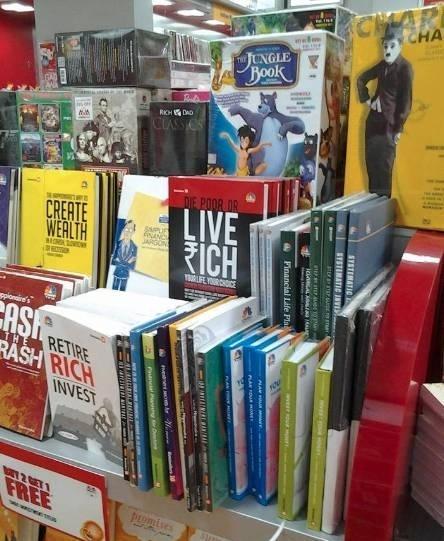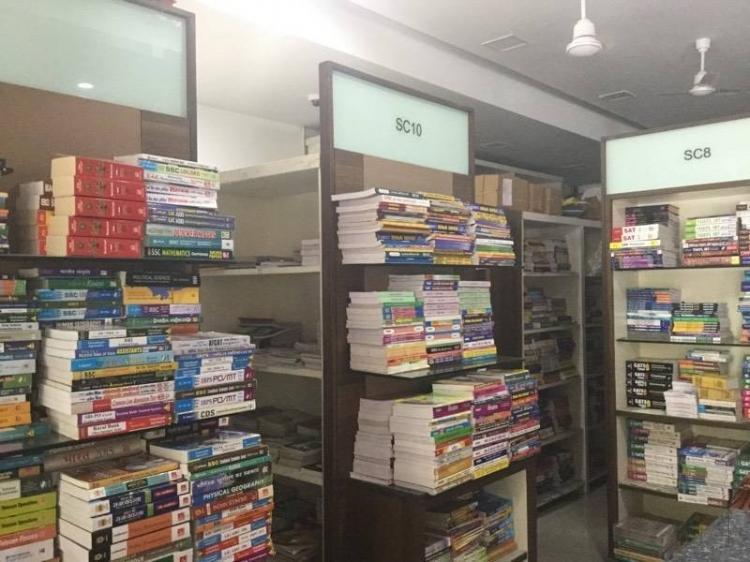The first image is the image on the left, the second image is the image on the right. For the images shown, is this caption "Shelves line the wall in the bookstore." true? Answer yes or no. No. 